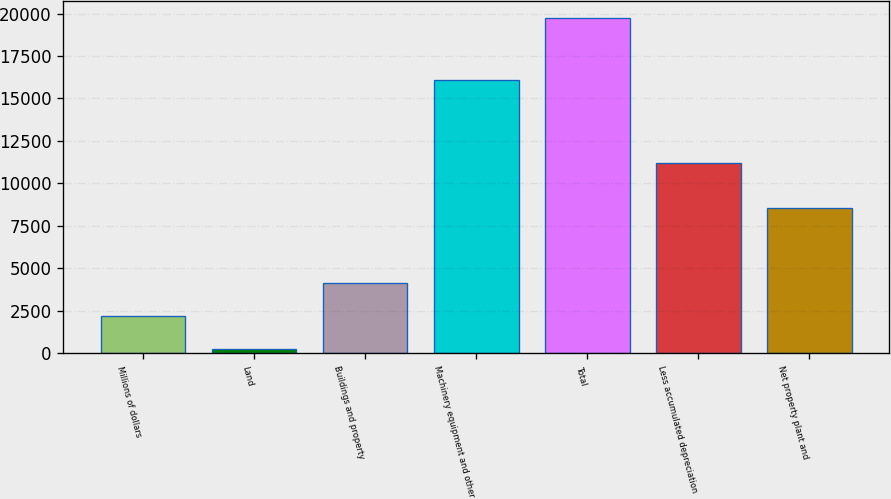<chart> <loc_0><loc_0><loc_500><loc_500><bar_chart><fcel>Millions of dollars<fcel>Land<fcel>Buildings and property<fcel>Machinery equipment and other<fcel>Total<fcel>Less accumulated depreciation<fcel>Net property plant and<nl><fcel>2178.2<fcel>228<fcel>4128.4<fcel>16103<fcel>19730<fcel>11198<fcel>8532<nl></chart> 